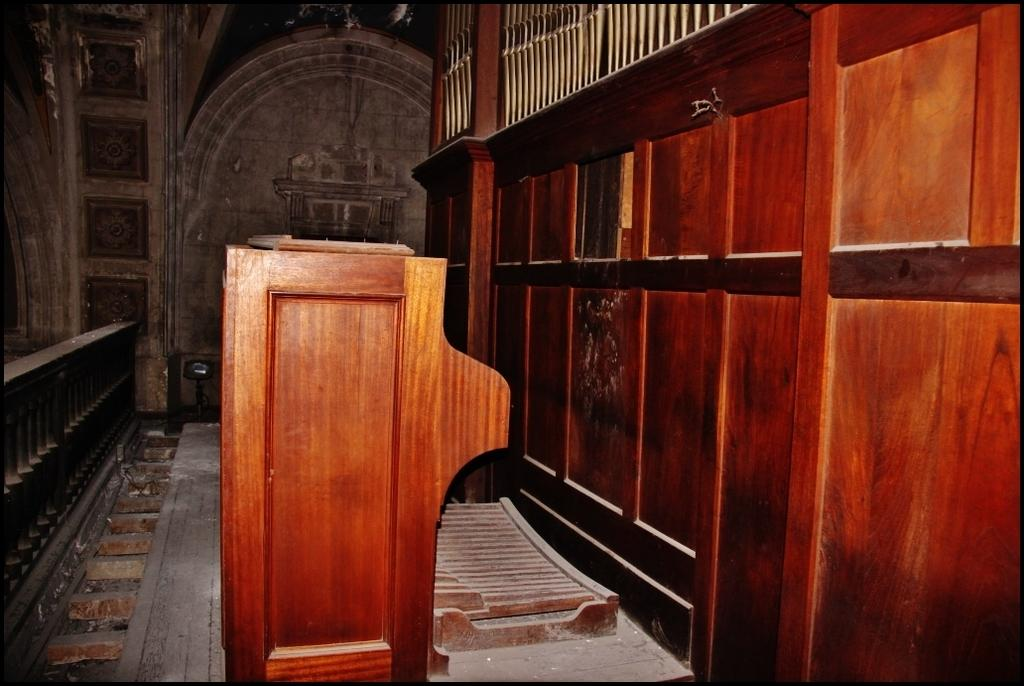What is the main object in the center of the image? There is a desk in the center of the image. What type of material is used for the wall on the right side of the image? There is a wooden wall on the right side of the image. What can be found on the right side of the image besides the wooden wall? There is a grill on the right side of the image. What is visible in the background of the image? There is a wall visible in the background of the image. What type of game is being played on the street in the image? There is no game or street present in the image; it features a desk, a wooden wall, a grill, and a wall in the background. 